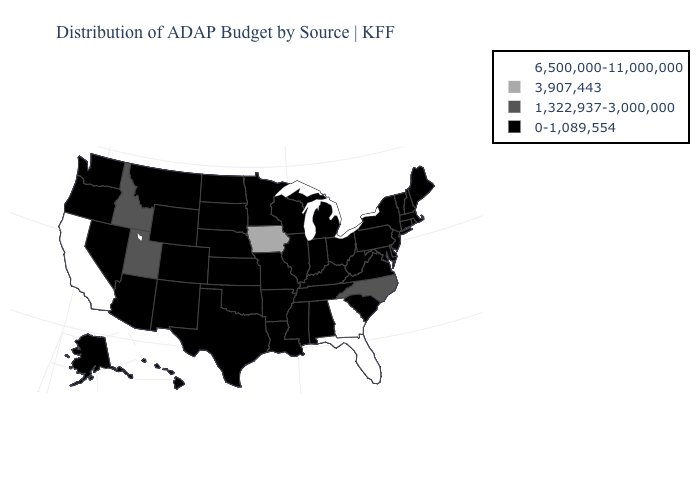Name the states that have a value in the range 0-1,089,554?
Be succinct. Alabama, Alaska, Arizona, Arkansas, Colorado, Connecticut, Delaware, Hawaii, Illinois, Indiana, Kansas, Kentucky, Louisiana, Maine, Maryland, Massachusetts, Michigan, Minnesota, Mississippi, Missouri, Montana, Nebraska, Nevada, New Hampshire, New Jersey, New Mexico, New York, North Dakota, Ohio, Oklahoma, Oregon, Pennsylvania, Rhode Island, South Carolina, South Dakota, Tennessee, Texas, Vermont, Virginia, Washington, West Virginia, Wisconsin, Wyoming. Name the states that have a value in the range 1,322,937-3,000,000?
Answer briefly. Idaho, North Carolina, Utah. What is the highest value in states that border New Mexico?
Concise answer only. 1,322,937-3,000,000. What is the value of Utah?
Write a very short answer. 1,322,937-3,000,000. Does Iowa have the lowest value in the MidWest?
Concise answer only. No. Which states have the highest value in the USA?
Concise answer only. California, Florida, Georgia. Which states have the lowest value in the MidWest?
Write a very short answer. Illinois, Indiana, Kansas, Michigan, Minnesota, Missouri, Nebraska, North Dakota, Ohio, South Dakota, Wisconsin. What is the value of Tennessee?
Answer briefly. 0-1,089,554. Does Texas have the lowest value in the South?
Write a very short answer. Yes. What is the lowest value in states that border Nebraska?
Quick response, please. 0-1,089,554. What is the value of New Hampshire?
Keep it brief. 0-1,089,554. What is the lowest value in the Northeast?
Answer briefly. 0-1,089,554. Does the first symbol in the legend represent the smallest category?
Answer briefly. No. Is the legend a continuous bar?
Answer briefly. No. 